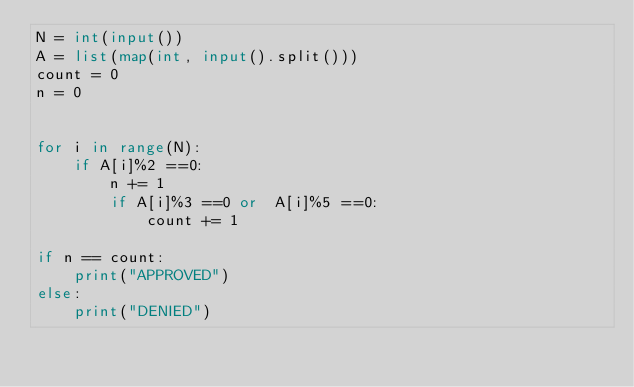<code> <loc_0><loc_0><loc_500><loc_500><_Python_>N = int(input())
A = list(map(int, input().split()))
count = 0
n = 0


for i in range(N):
    if A[i]%2 ==0:
        n += 1
        if A[i]%3 ==0 or  A[i]%5 ==0:
            count += 1

if n == count:
    print("APPROVED")
else:
    print("DENIED")            



</code> 